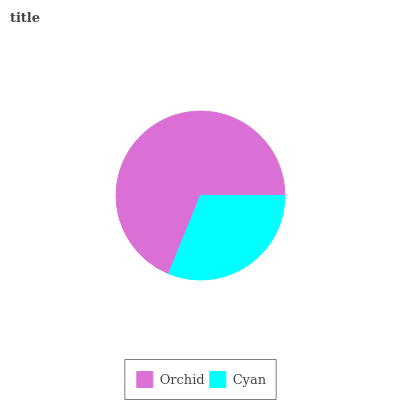Is Cyan the minimum?
Answer yes or no. Yes. Is Orchid the maximum?
Answer yes or no. Yes. Is Cyan the maximum?
Answer yes or no. No. Is Orchid greater than Cyan?
Answer yes or no. Yes. Is Cyan less than Orchid?
Answer yes or no. Yes. Is Cyan greater than Orchid?
Answer yes or no. No. Is Orchid less than Cyan?
Answer yes or no. No. Is Orchid the high median?
Answer yes or no. Yes. Is Cyan the low median?
Answer yes or no. Yes. Is Cyan the high median?
Answer yes or no. No. Is Orchid the low median?
Answer yes or no. No. 